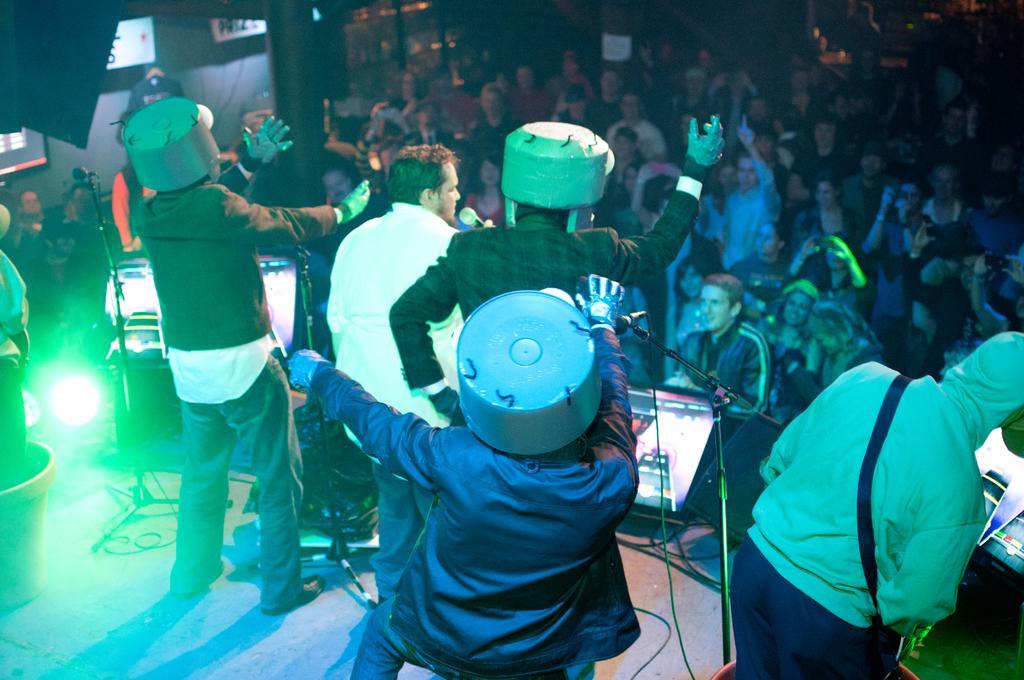Can you describe this image briefly? This picture describes about group of people, and we can see few people on the stage, they are musicians, in front of them we can find microphones, monitors and lights. 